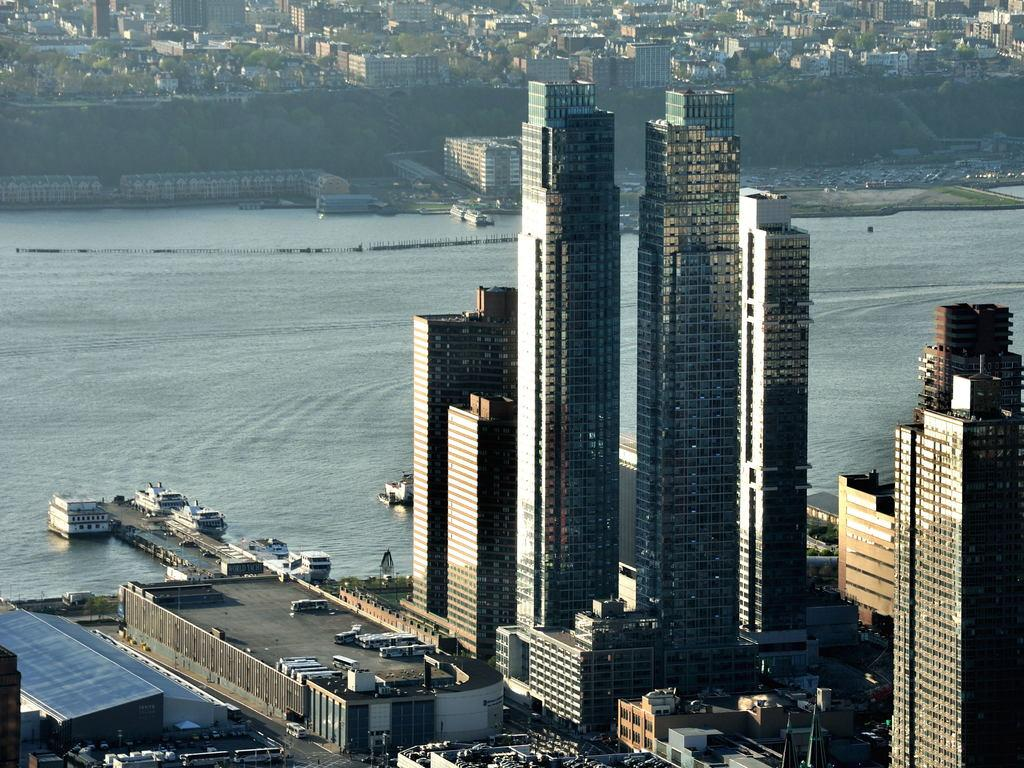What type of structures can be seen on the right side of the image? There are big buildings on the right side of the image. What is located in the middle of the image? There is water in the middle of the image. What is present on the water in the image? There are ships on the water. Can you see a skate being used by someone in the image? There is no skate present in the image. Is there a hat visible on any of the ships in the image? There is no hat visible on any of the ships in the image. 